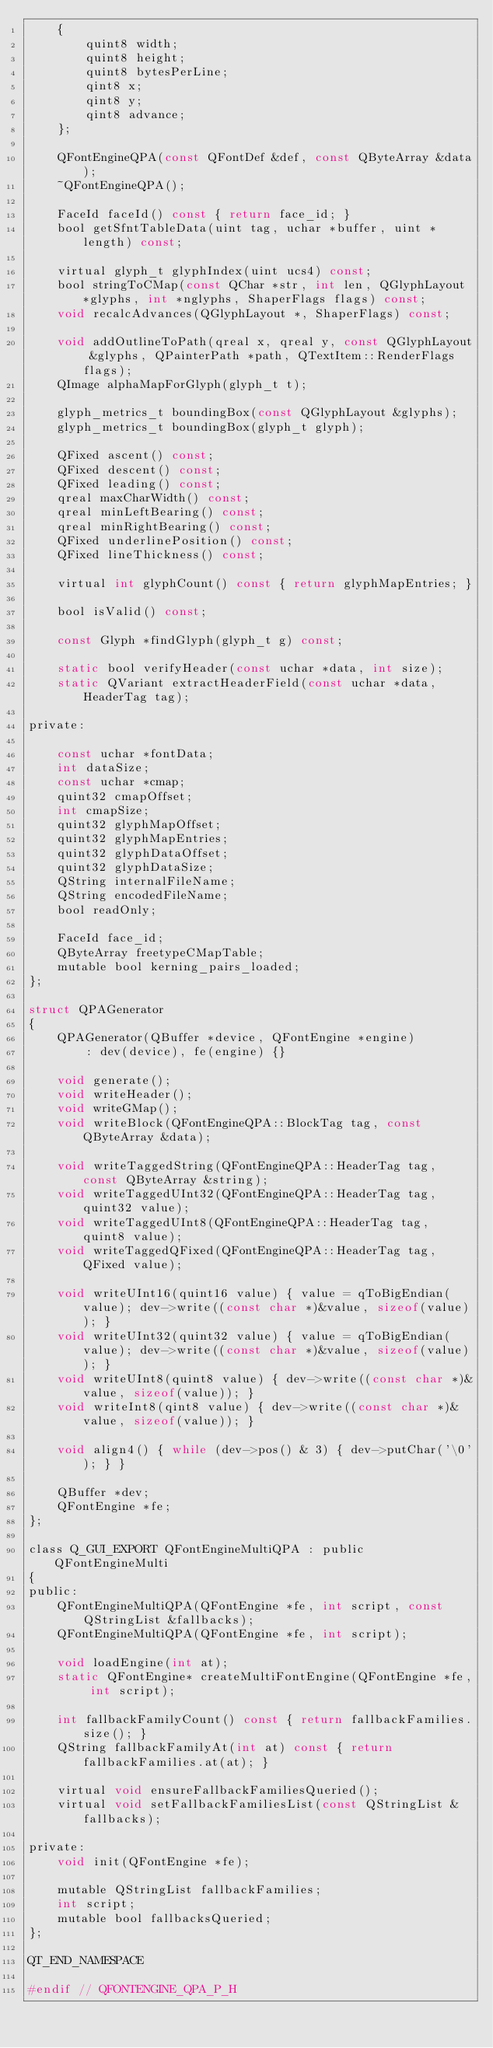Convert code to text. <code><loc_0><loc_0><loc_500><loc_500><_C_>    {
        quint8 width;
        quint8 height;
        quint8 bytesPerLine;
        qint8 x;
        qint8 y;
        qint8 advance;
    };

    QFontEngineQPA(const QFontDef &def, const QByteArray &data);
    ~QFontEngineQPA();

    FaceId faceId() const { return face_id; }
    bool getSfntTableData(uint tag, uchar *buffer, uint *length) const;

    virtual glyph_t glyphIndex(uint ucs4) const;
    bool stringToCMap(const QChar *str, int len, QGlyphLayout *glyphs, int *nglyphs, ShaperFlags flags) const;
    void recalcAdvances(QGlyphLayout *, ShaperFlags) const;

    void addOutlineToPath(qreal x, qreal y, const QGlyphLayout &glyphs, QPainterPath *path, QTextItem::RenderFlags flags);
    QImage alphaMapForGlyph(glyph_t t);

    glyph_metrics_t boundingBox(const QGlyphLayout &glyphs);
    glyph_metrics_t boundingBox(glyph_t glyph);

    QFixed ascent() const;
    QFixed descent() const;
    QFixed leading() const;
    qreal maxCharWidth() const;
    qreal minLeftBearing() const;
    qreal minRightBearing() const;
    QFixed underlinePosition() const;
    QFixed lineThickness() const;

    virtual int glyphCount() const { return glyphMapEntries; }

    bool isValid() const;

    const Glyph *findGlyph(glyph_t g) const;

    static bool verifyHeader(const uchar *data, int size);
    static QVariant extractHeaderField(const uchar *data, HeaderTag tag);

private:

    const uchar *fontData;
    int dataSize;
    const uchar *cmap;
    quint32 cmapOffset;
    int cmapSize;
    quint32 glyphMapOffset;
    quint32 glyphMapEntries;
    quint32 glyphDataOffset;
    quint32 glyphDataSize;
    QString internalFileName;
    QString encodedFileName;
    bool readOnly;

    FaceId face_id;
    QByteArray freetypeCMapTable;
    mutable bool kerning_pairs_loaded;
};

struct QPAGenerator
{
    QPAGenerator(QBuffer *device, QFontEngine *engine)
        : dev(device), fe(engine) {}

    void generate();
    void writeHeader();
    void writeGMap();
    void writeBlock(QFontEngineQPA::BlockTag tag, const QByteArray &data);

    void writeTaggedString(QFontEngineQPA::HeaderTag tag, const QByteArray &string);
    void writeTaggedUInt32(QFontEngineQPA::HeaderTag tag, quint32 value);
    void writeTaggedUInt8(QFontEngineQPA::HeaderTag tag, quint8 value);
    void writeTaggedQFixed(QFontEngineQPA::HeaderTag tag, QFixed value);

    void writeUInt16(quint16 value) { value = qToBigEndian(value); dev->write((const char *)&value, sizeof(value)); }
    void writeUInt32(quint32 value) { value = qToBigEndian(value); dev->write((const char *)&value, sizeof(value)); }
    void writeUInt8(quint8 value) { dev->write((const char *)&value, sizeof(value)); }
    void writeInt8(qint8 value) { dev->write((const char *)&value, sizeof(value)); }

    void align4() { while (dev->pos() & 3) { dev->putChar('\0'); } }

    QBuffer *dev;
    QFontEngine *fe;
};

class Q_GUI_EXPORT QFontEngineMultiQPA : public QFontEngineMulti
{
public:
    QFontEngineMultiQPA(QFontEngine *fe, int script, const QStringList &fallbacks);
    QFontEngineMultiQPA(QFontEngine *fe, int script);

    void loadEngine(int at);
    static QFontEngine* createMultiFontEngine(QFontEngine *fe, int script);

    int fallbackFamilyCount() const { return fallbackFamilies.size(); }
    QString fallbackFamilyAt(int at) const { return fallbackFamilies.at(at); }

    virtual void ensureFallbackFamiliesQueried();
    virtual void setFallbackFamiliesList(const QStringList &fallbacks);

private:
    void init(QFontEngine *fe);

    mutable QStringList fallbackFamilies;
    int script;
    mutable bool fallbacksQueried;
};

QT_END_NAMESPACE

#endif // QFONTENGINE_QPA_P_H
</code> 